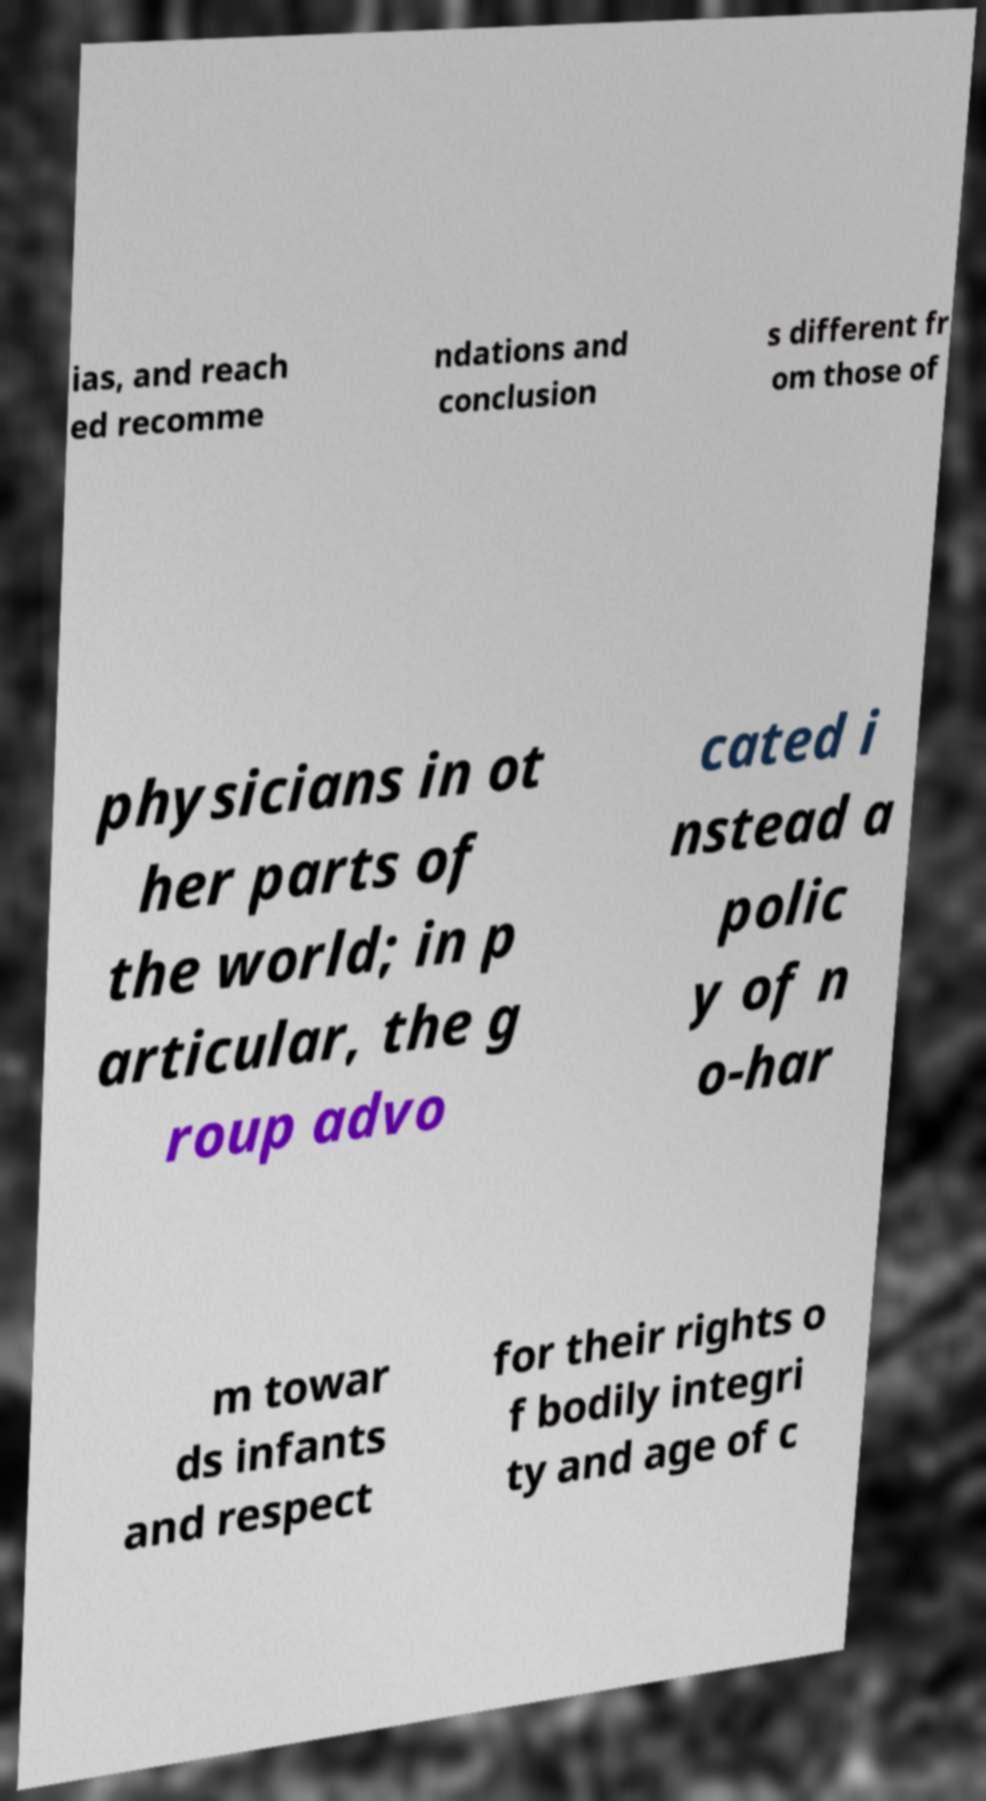I need the written content from this picture converted into text. Can you do that? ias, and reach ed recomme ndations and conclusion s different fr om those of physicians in ot her parts of the world; in p articular, the g roup advo cated i nstead a polic y of n o-har m towar ds infants and respect for their rights o f bodily integri ty and age of c 